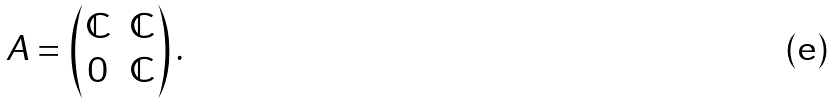Convert formula to latex. <formula><loc_0><loc_0><loc_500><loc_500>A = \begin{pmatrix} \mathbb { C } & \mathbb { C } \\ 0 & \mathbb { C } \end{pmatrix} .</formula> 